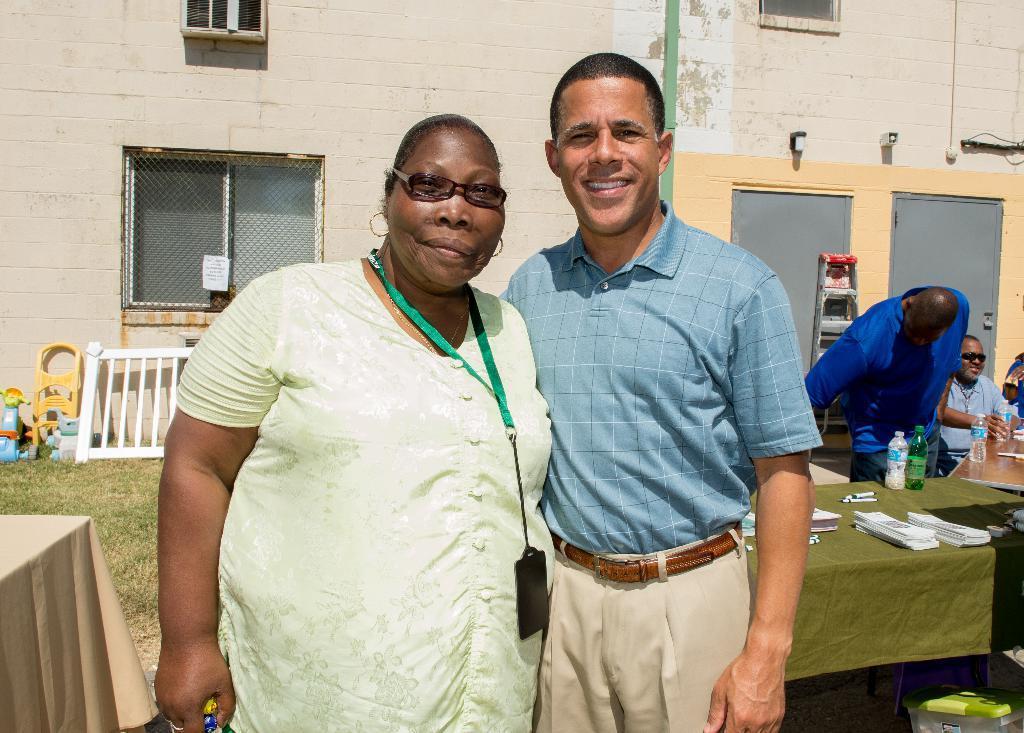How would you summarize this image in a sentence or two? A woman wearing a specs and a tag is standing. Near to her a person is standing. And there is a table. On the table there are papers pen bottles. And some people are there in the right side. In the background there is a building, windows, to, grass lawns, and a ladder. 